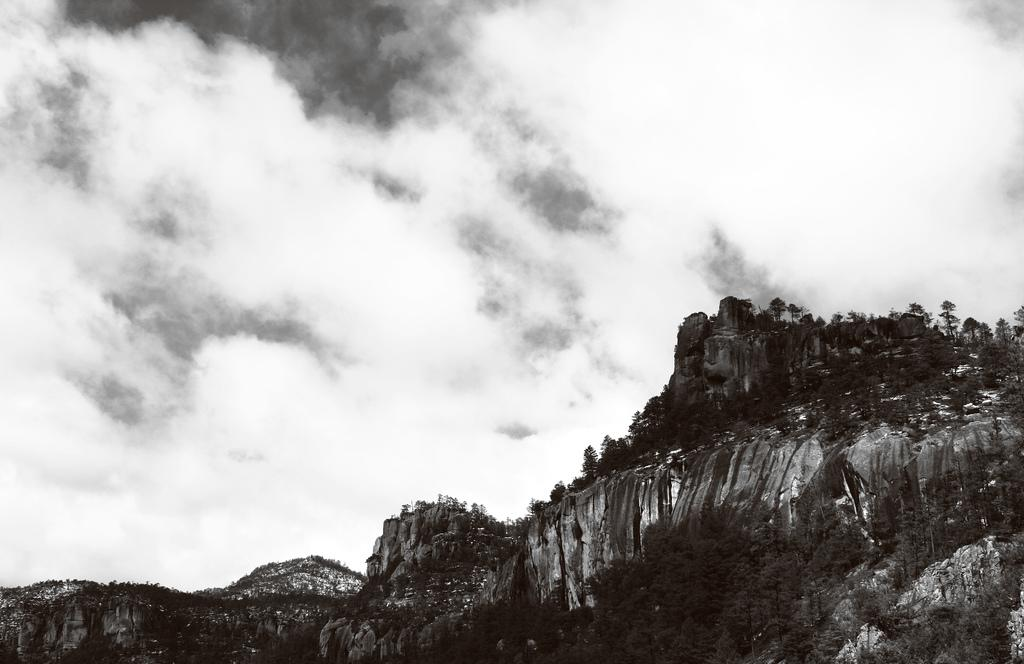What type of natural elements can be seen in the image? There are trees and clouds in the image. What is the color scheme of the image? The image is black and white in color. What type of toys can be seen in the image? There are no toys present in the image; it features trees and clouds in a black and white color scheme. What type of produce is being harvested in the image? There is no produce or harvesting activity depicted in the image; it features trees and clouds in a black and white color scheme. 